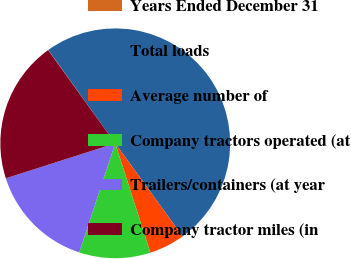Convert chart. <chart><loc_0><loc_0><loc_500><loc_500><pie_chart><fcel>Years Ended December 31<fcel>Total loads<fcel>Average number of<fcel>Company tractors operated (at<fcel>Trailers/containers (at year<fcel>Company tractor miles (in<nl><fcel>0.04%<fcel>49.92%<fcel>5.03%<fcel>10.02%<fcel>15.0%<fcel>19.99%<nl></chart> 